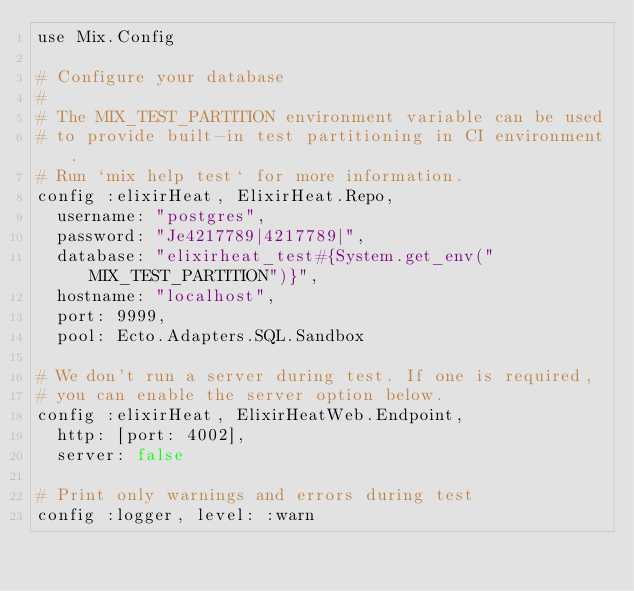Convert code to text. <code><loc_0><loc_0><loc_500><loc_500><_Elixir_>use Mix.Config

# Configure your database
#
# The MIX_TEST_PARTITION environment variable can be used
# to provide built-in test partitioning in CI environment.
# Run `mix help test` for more information.
config :elixirHeat, ElixirHeat.Repo,
  username: "postgres",
  password: "Je4217789|4217789|",
  database: "elixirheat_test#{System.get_env("MIX_TEST_PARTITION")}",
  hostname: "localhost",
  port: 9999,
  pool: Ecto.Adapters.SQL.Sandbox

# We don't run a server during test. If one is required,
# you can enable the server option below.
config :elixirHeat, ElixirHeatWeb.Endpoint,
  http: [port: 4002],
  server: false

# Print only warnings and errors during test
config :logger, level: :warn
</code> 